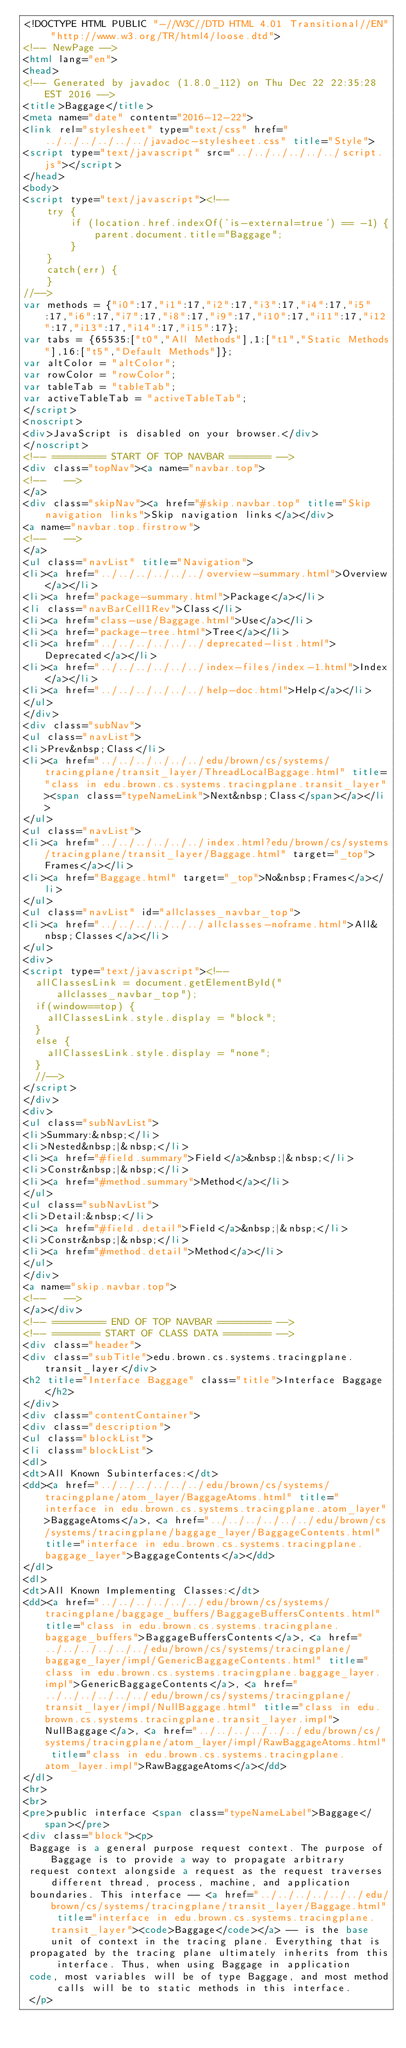<code> <loc_0><loc_0><loc_500><loc_500><_HTML_><!DOCTYPE HTML PUBLIC "-//W3C//DTD HTML 4.01 Transitional//EN" "http://www.w3.org/TR/html4/loose.dtd">
<!-- NewPage -->
<html lang="en">
<head>
<!-- Generated by javadoc (1.8.0_112) on Thu Dec 22 22:35:28 EST 2016 -->
<title>Baggage</title>
<meta name="date" content="2016-12-22">
<link rel="stylesheet" type="text/css" href="../../../../../../javadoc-stylesheet.css" title="Style">
<script type="text/javascript" src="../../../../../../script.js"></script>
</head>
<body>
<script type="text/javascript"><!--
    try {
        if (location.href.indexOf('is-external=true') == -1) {
            parent.document.title="Baggage";
        }
    }
    catch(err) {
    }
//-->
var methods = {"i0":17,"i1":17,"i2":17,"i3":17,"i4":17,"i5":17,"i6":17,"i7":17,"i8":17,"i9":17,"i10":17,"i11":17,"i12":17,"i13":17,"i14":17,"i15":17};
var tabs = {65535:["t0","All Methods"],1:["t1","Static Methods"],16:["t5","Default Methods"]};
var altColor = "altColor";
var rowColor = "rowColor";
var tableTab = "tableTab";
var activeTableTab = "activeTableTab";
</script>
<noscript>
<div>JavaScript is disabled on your browser.</div>
</noscript>
<!-- ========= START OF TOP NAVBAR ======= -->
<div class="topNav"><a name="navbar.top">
<!--   -->
</a>
<div class="skipNav"><a href="#skip.navbar.top" title="Skip navigation links">Skip navigation links</a></div>
<a name="navbar.top.firstrow">
<!--   -->
</a>
<ul class="navList" title="Navigation">
<li><a href="../../../../../../overview-summary.html">Overview</a></li>
<li><a href="package-summary.html">Package</a></li>
<li class="navBarCell1Rev">Class</li>
<li><a href="class-use/Baggage.html">Use</a></li>
<li><a href="package-tree.html">Tree</a></li>
<li><a href="../../../../../../deprecated-list.html">Deprecated</a></li>
<li><a href="../../../../../../index-files/index-1.html">Index</a></li>
<li><a href="../../../../../../help-doc.html">Help</a></li>
</ul>
</div>
<div class="subNav">
<ul class="navList">
<li>Prev&nbsp;Class</li>
<li><a href="../../../../../../edu/brown/cs/systems/tracingplane/transit_layer/ThreadLocalBaggage.html" title="class in edu.brown.cs.systems.tracingplane.transit_layer"><span class="typeNameLink">Next&nbsp;Class</span></a></li>
</ul>
<ul class="navList">
<li><a href="../../../../../../index.html?edu/brown/cs/systems/tracingplane/transit_layer/Baggage.html" target="_top">Frames</a></li>
<li><a href="Baggage.html" target="_top">No&nbsp;Frames</a></li>
</ul>
<ul class="navList" id="allclasses_navbar_top">
<li><a href="../../../../../../allclasses-noframe.html">All&nbsp;Classes</a></li>
</ul>
<div>
<script type="text/javascript"><!--
  allClassesLink = document.getElementById("allclasses_navbar_top");
  if(window==top) {
    allClassesLink.style.display = "block";
  }
  else {
    allClassesLink.style.display = "none";
  }
  //-->
</script>
</div>
<div>
<ul class="subNavList">
<li>Summary:&nbsp;</li>
<li>Nested&nbsp;|&nbsp;</li>
<li><a href="#field.summary">Field</a>&nbsp;|&nbsp;</li>
<li>Constr&nbsp;|&nbsp;</li>
<li><a href="#method.summary">Method</a></li>
</ul>
<ul class="subNavList">
<li>Detail:&nbsp;</li>
<li><a href="#field.detail">Field</a>&nbsp;|&nbsp;</li>
<li>Constr&nbsp;|&nbsp;</li>
<li><a href="#method.detail">Method</a></li>
</ul>
</div>
<a name="skip.navbar.top">
<!--   -->
</a></div>
<!-- ========= END OF TOP NAVBAR ========= -->
<!-- ======== START OF CLASS DATA ======== -->
<div class="header">
<div class="subTitle">edu.brown.cs.systems.tracingplane.transit_layer</div>
<h2 title="Interface Baggage" class="title">Interface Baggage</h2>
</div>
<div class="contentContainer">
<div class="description">
<ul class="blockList">
<li class="blockList">
<dl>
<dt>All Known Subinterfaces:</dt>
<dd><a href="../../../../../../edu/brown/cs/systems/tracingplane/atom_layer/BaggageAtoms.html" title="interface in edu.brown.cs.systems.tracingplane.atom_layer">BaggageAtoms</a>, <a href="../../../../../../edu/brown/cs/systems/tracingplane/baggage_layer/BaggageContents.html" title="interface in edu.brown.cs.systems.tracingplane.baggage_layer">BaggageContents</a></dd>
</dl>
<dl>
<dt>All Known Implementing Classes:</dt>
<dd><a href="../../../../../../edu/brown/cs/systems/tracingplane/baggage_buffers/BaggageBuffersContents.html" title="class in edu.brown.cs.systems.tracingplane.baggage_buffers">BaggageBuffersContents</a>, <a href="../../../../../../edu/brown/cs/systems/tracingplane/baggage_layer/impl/GenericBaggageContents.html" title="class in edu.brown.cs.systems.tracingplane.baggage_layer.impl">GenericBaggageContents</a>, <a href="../../../../../../edu/brown/cs/systems/tracingplane/transit_layer/impl/NullBaggage.html" title="class in edu.brown.cs.systems.tracingplane.transit_layer.impl">NullBaggage</a>, <a href="../../../../../../edu/brown/cs/systems/tracingplane/atom_layer/impl/RawBaggageAtoms.html" title="class in edu.brown.cs.systems.tracingplane.atom_layer.impl">RawBaggageAtoms</a></dd>
</dl>
<hr>
<br>
<pre>public interface <span class="typeNameLabel">Baggage</span></pre>
<div class="block"><p>
 Baggage is a general purpose request context. The purpose of Baggage is to provide a way to propagate arbitrary
 request context alongside a request as the request traverses different thread, process, machine, and application
 boundaries. This interface -- <a href="../../../../../../edu/brown/cs/systems/tracingplane/transit_layer/Baggage.html" title="interface in edu.brown.cs.systems.tracingplane.transit_layer"><code>Baggage</code></a> -- is the base unit of context in the tracing plane. Everything that is
 propagated by the tracing plane ultimately inherits from this interface. Thus, when using Baggage in application
 code, most variables will be of type Baggage, and most method calls will be to static methods in this interface.
 </p>
 </code> 